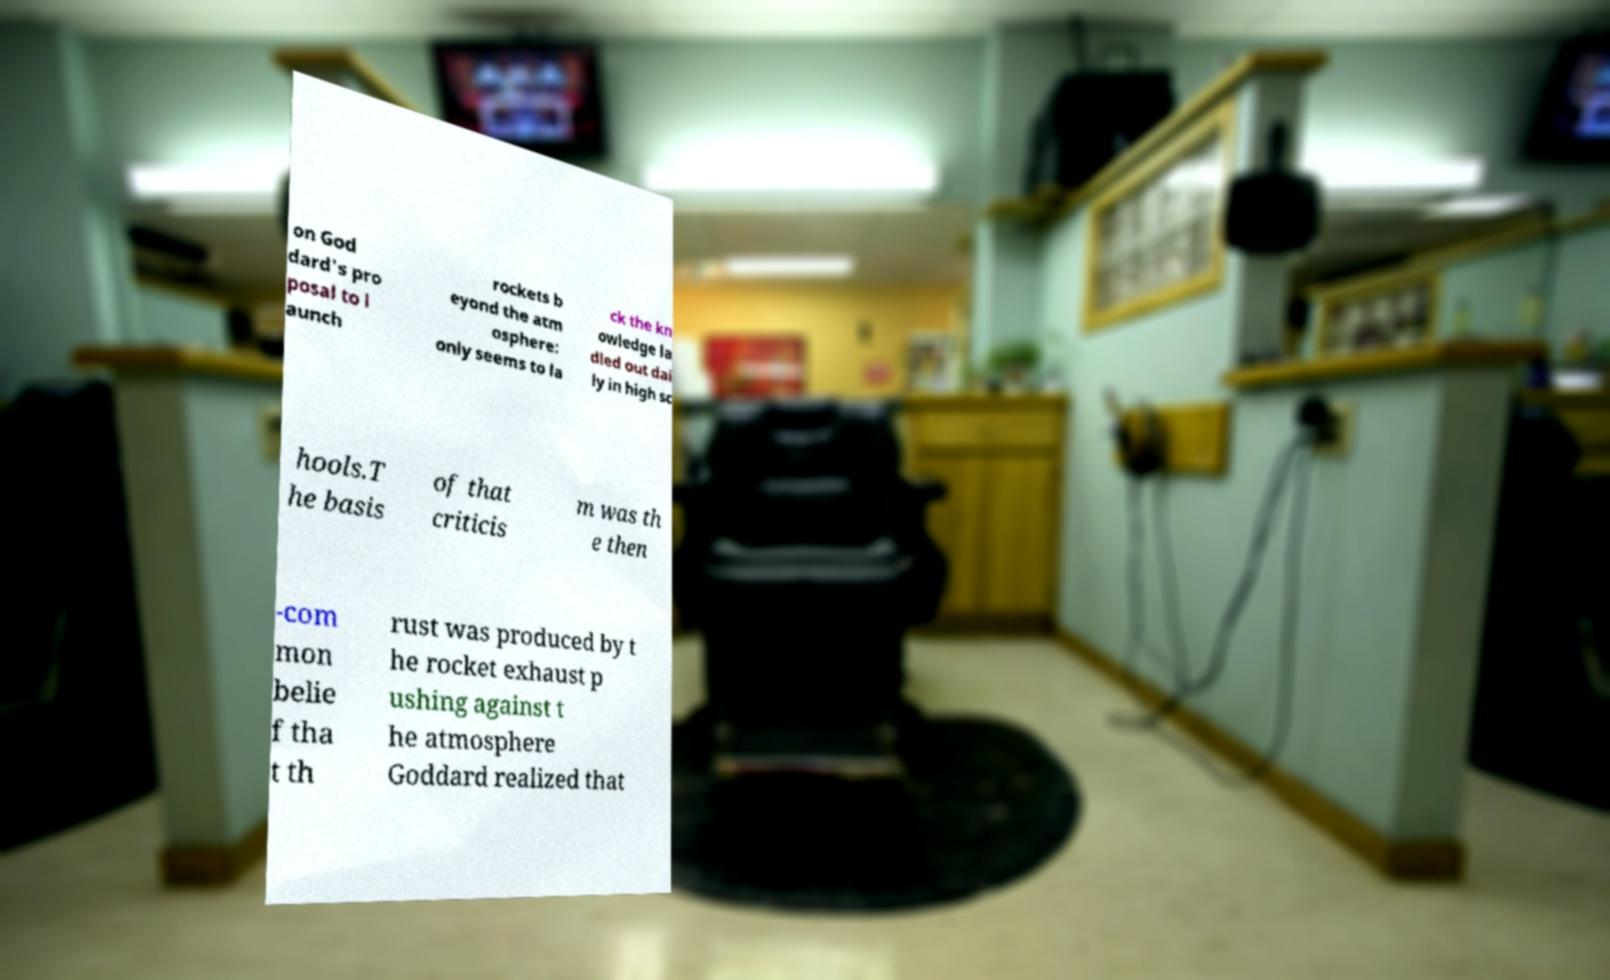For documentation purposes, I need the text within this image transcribed. Could you provide that? on God dard's pro posal to l aunch rockets b eyond the atm osphere: only seems to la ck the kn owledge la dled out dai ly in high sc hools.T he basis of that criticis m was th e then -com mon belie f tha t th rust was produced by t he rocket exhaust p ushing against t he atmosphere Goddard realized that 